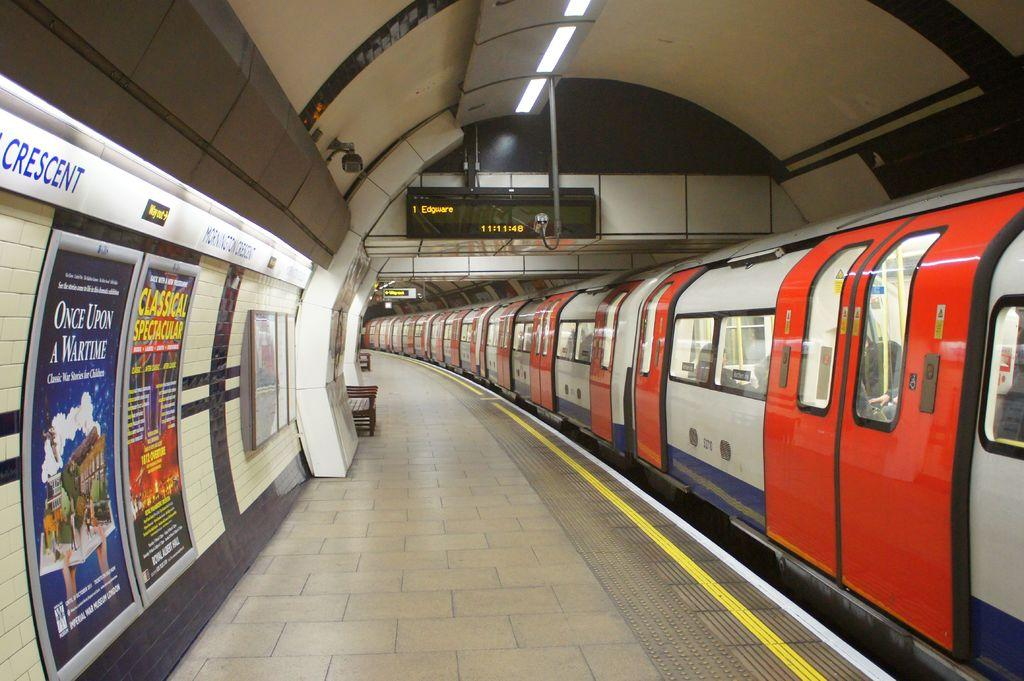<image>
Describe the image concisely. Red and silver train in a subway that has a ticker sayingEdgware. 